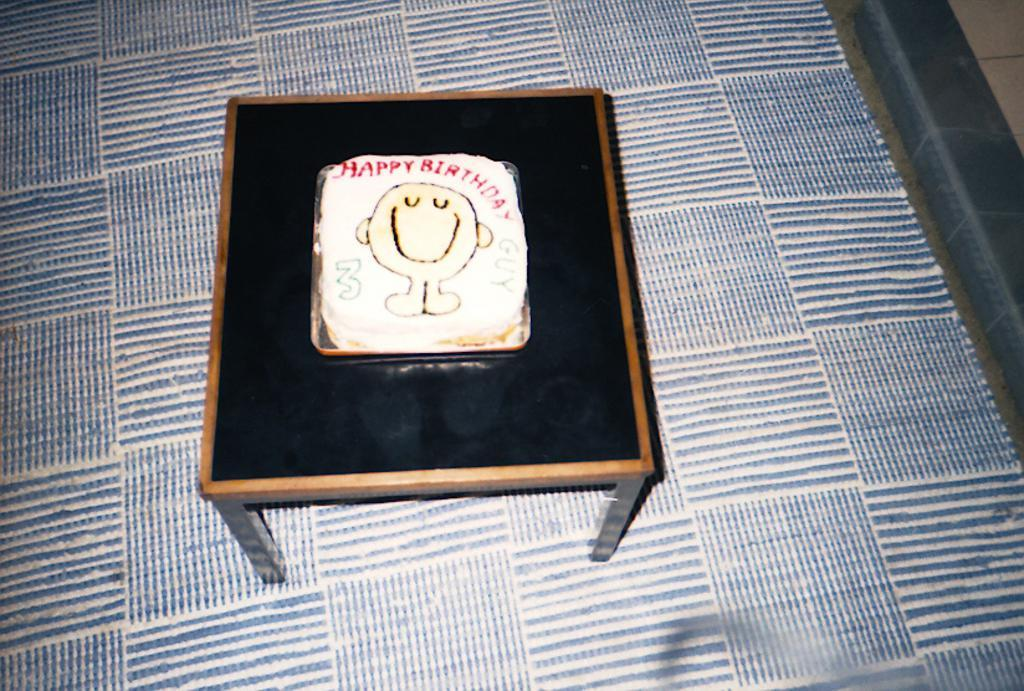What is the main subject of the image? There is a cake in the image. How is the cake positioned in the image? The cake is in a tray. Where is the tray with the cake located? The tray is placed on a table. What type of flooring is visible in the image? There is a carpet on the floor in the image. What type of wood can be seen in the image? There is no wood visible in the image. How does the light change throughout the image? The image does not depict any changes in light, as it is a still image. 